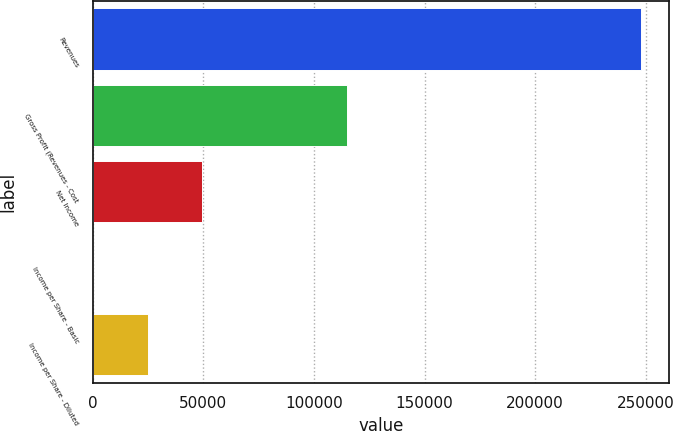Convert chart. <chart><loc_0><loc_0><loc_500><loc_500><bar_chart><fcel>Revenues<fcel>Gross Profit (Revenues - Cost<fcel>Net Income<fcel>Income per Share - Basic<fcel>Income per Share - Diluted<nl><fcel>248076<fcel>115026<fcel>49615.3<fcel>0.13<fcel>24807.7<nl></chart> 